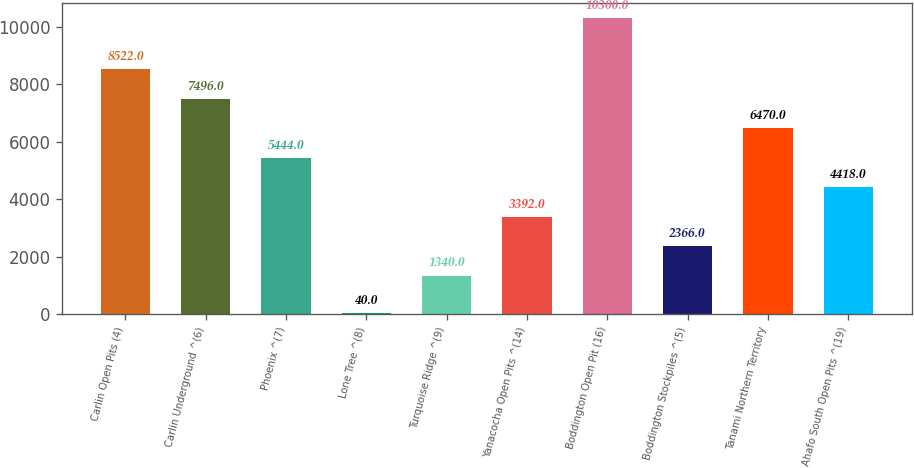Convert chart to OTSL. <chart><loc_0><loc_0><loc_500><loc_500><bar_chart><fcel>Carlin Open Pits (4)<fcel>Carlin Underground ^(6)<fcel>Phoenix ^(7)<fcel>Lone Tree ^(8)<fcel>Turquoise Ridge ^(9)<fcel>Yanacocha Open Pits ^(14)<fcel>Boddington Open Pit (16)<fcel>Boddington Stockpiles ^(5)<fcel>Tanami Northern Territory<fcel>Ahafo South Open Pits ^(19)<nl><fcel>8522<fcel>7496<fcel>5444<fcel>40<fcel>1340<fcel>3392<fcel>10300<fcel>2366<fcel>6470<fcel>4418<nl></chart> 